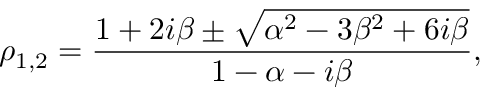Convert formula to latex. <formula><loc_0><loc_0><loc_500><loc_500>\rho _ { 1 , 2 } = \frac { 1 + 2 i \beta \pm \sqrt { \alpha ^ { 2 } - 3 \beta ^ { 2 } + 6 i \beta } } { 1 - \alpha - i \beta } ,</formula> 